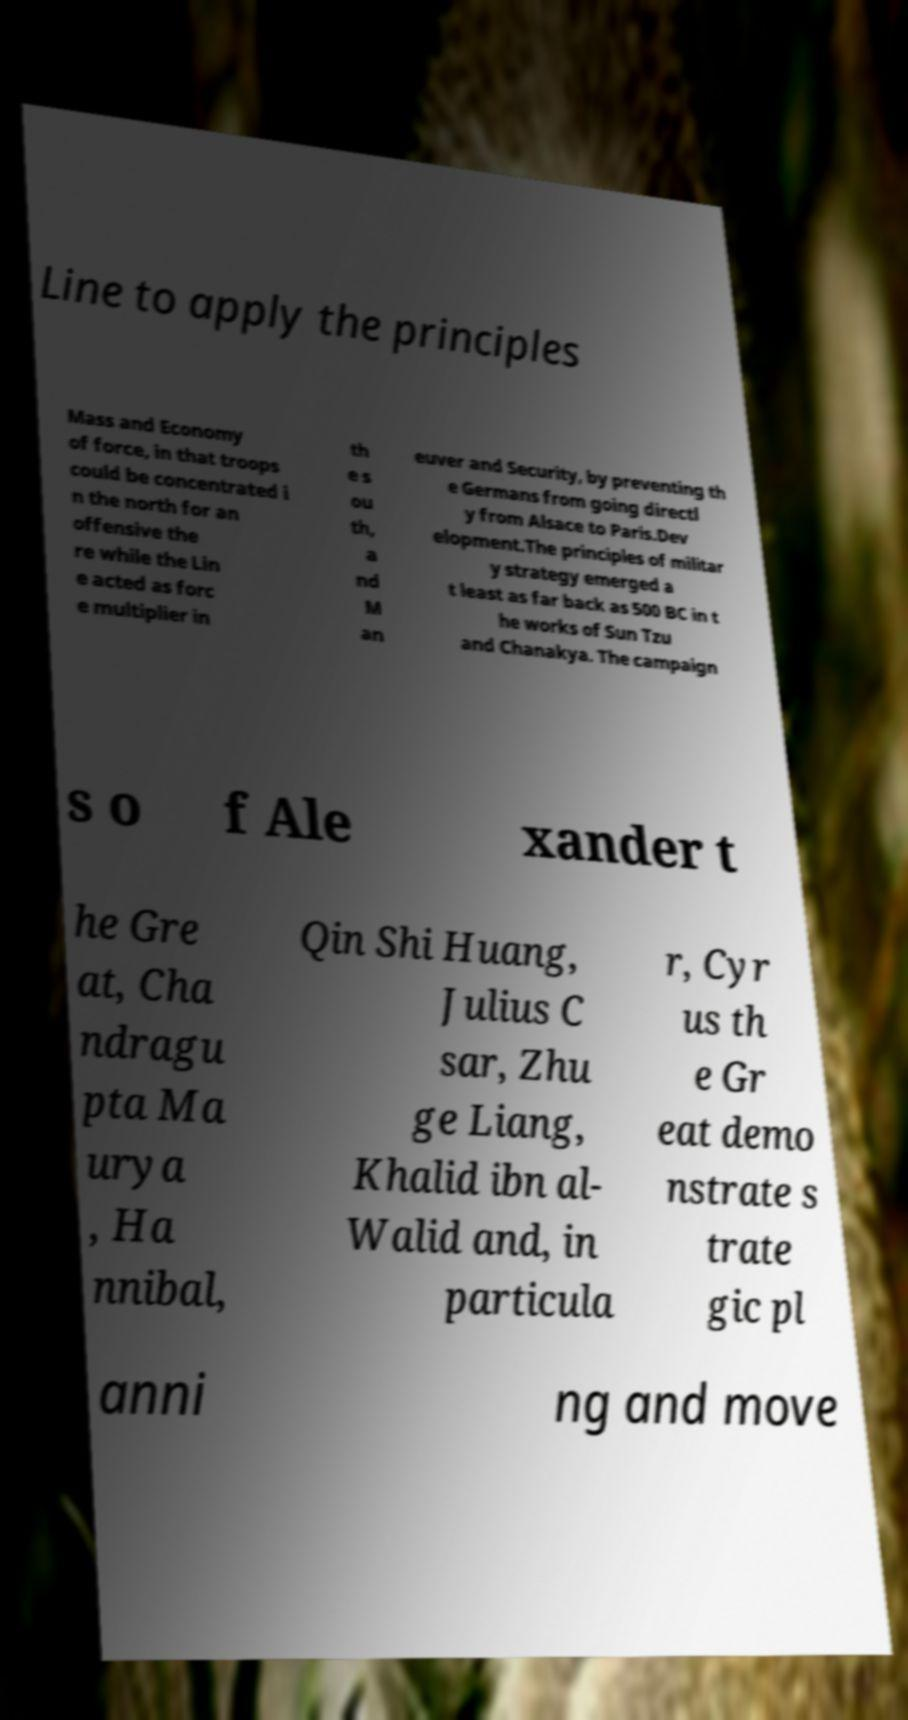For documentation purposes, I need the text within this image transcribed. Could you provide that? Line to apply the principles Mass and Economy of force, in that troops could be concentrated i n the north for an offensive the re while the Lin e acted as forc e multiplier in th e s ou th, a nd M an euver and Security, by preventing th e Germans from going directl y from Alsace to Paris.Dev elopment.The principles of militar y strategy emerged a t least as far back as 500 BC in t he works of Sun Tzu and Chanakya. The campaign s o f Ale xander t he Gre at, Cha ndragu pta Ma urya , Ha nnibal, Qin Shi Huang, Julius C sar, Zhu ge Liang, Khalid ibn al- Walid and, in particula r, Cyr us th e Gr eat demo nstrate s trate gic pl anni ng and move 